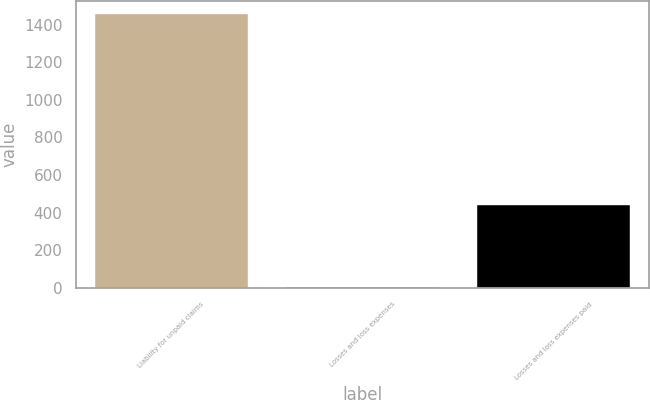<chart> <loc_0><loc_0><loc_500><loc_500><bar_chart><fcel>Liability for unpaid claims<fcel>Losses and loss expenses<fcel>Losses and loss expenses paid<nl><fcel>1454<fcel>5<fcel>440<nl></chart> 